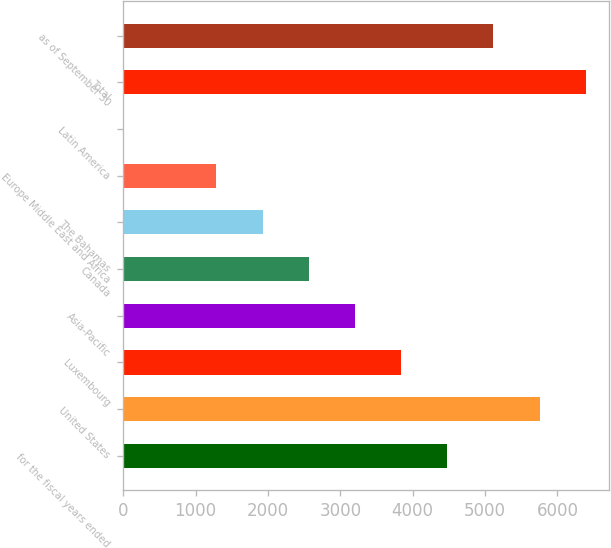Convert chart. <chart><loc_0><loc_0><loc_500><loc_500><bar_chart><fcel>for the fiscal years ended<fcel>United States<fcel>Luxembourg<fcel>Asia-Pacific<fcel>Canada<fcel>The Bahamas<fcel>Europe Middle East and Africa<fcel>Latin America<fcel>Total<fcel>as of September 30<nl><fcel>4477.57<fcel>5753.99<fcel>3839.36<fcel>3201.15<fcel>2562.94<fcel>1924.73<fcel>1286.52<fcel>10.1<fcel>6392.2<fcel>5115.78<nl></chart> 